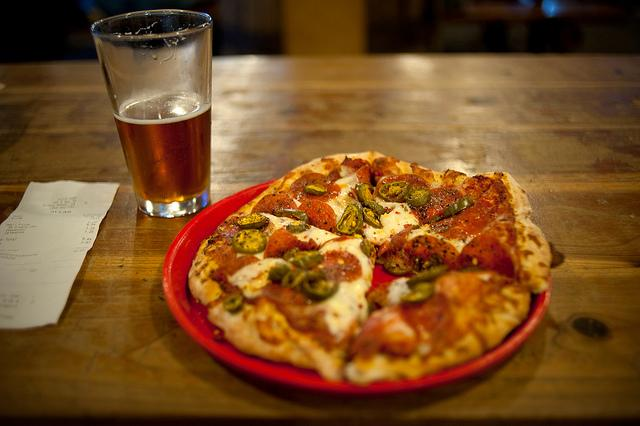What are the green items on top of the pizza?

Choices:
A) olives
B) green onions
C) green peppers
D) jalapenos jalapenos 